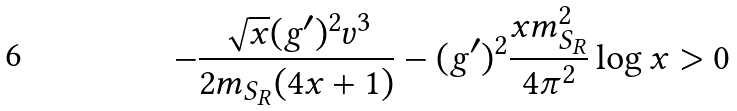Convert formula to latex. <formula><loc_0><loc_0><loc_500><loc_500>- \frac { \sqrt { x } ( g ^ { \prime } ) ^ { 2 } v ^ { 3 } } { 2 m _ { S _ { R } } ( 4 x + 1 ) } - ( g ^ { \prime } ) ^ { 2 } \frac { x m _ { S _ { R } } ^ { 2 } } { 4 \pi ^ { 2 } } \log x > 0</formula> 